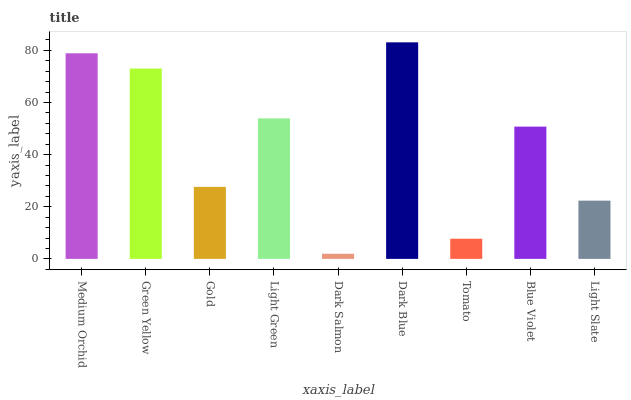Is Green Yellow the minimum?
Answer yes or no. No. Is Green Yellow the maximum?
Answer yes or no. No. Is Medium Orchid greater than Green Yellow?
Answer yes or no. Yes. Is Green Yellow less than Medium Orchid?
Answer yes or no. Yes. Is Green Yellow greater than Medium Orchid?
Answer yes or no. No. Is Medium Orchid less than Green Yellow?
Answer yes or no. No. Is Blue Violet the high median?
Answer yes or no. Yes. Is Blue Violet the low median?
Answer yes or no. Yes. Is Tomato the high median?
Answer yes or no. No. Is Light Slate the low median?
Answer yes or no. No. 